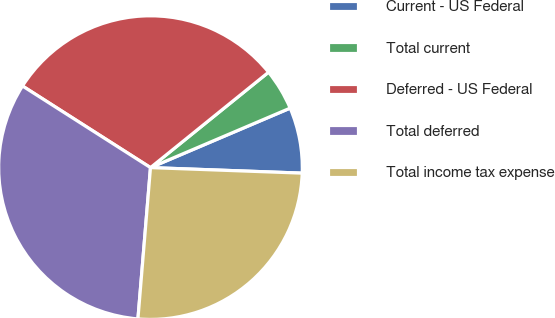<chart> <loc_0><loc_0><loc_500><loc_500><pie_chart><fcel>Current - US Federal<fcel>Total current<fcel>Deferred - US Federal<fcel>Total deferred<fcel>Total income tax expense<nl><fcel>6.99%<fcel>4.41%<fcel>30.15%<fcel>32.72%<fcel>25.74%<nl></chart> 